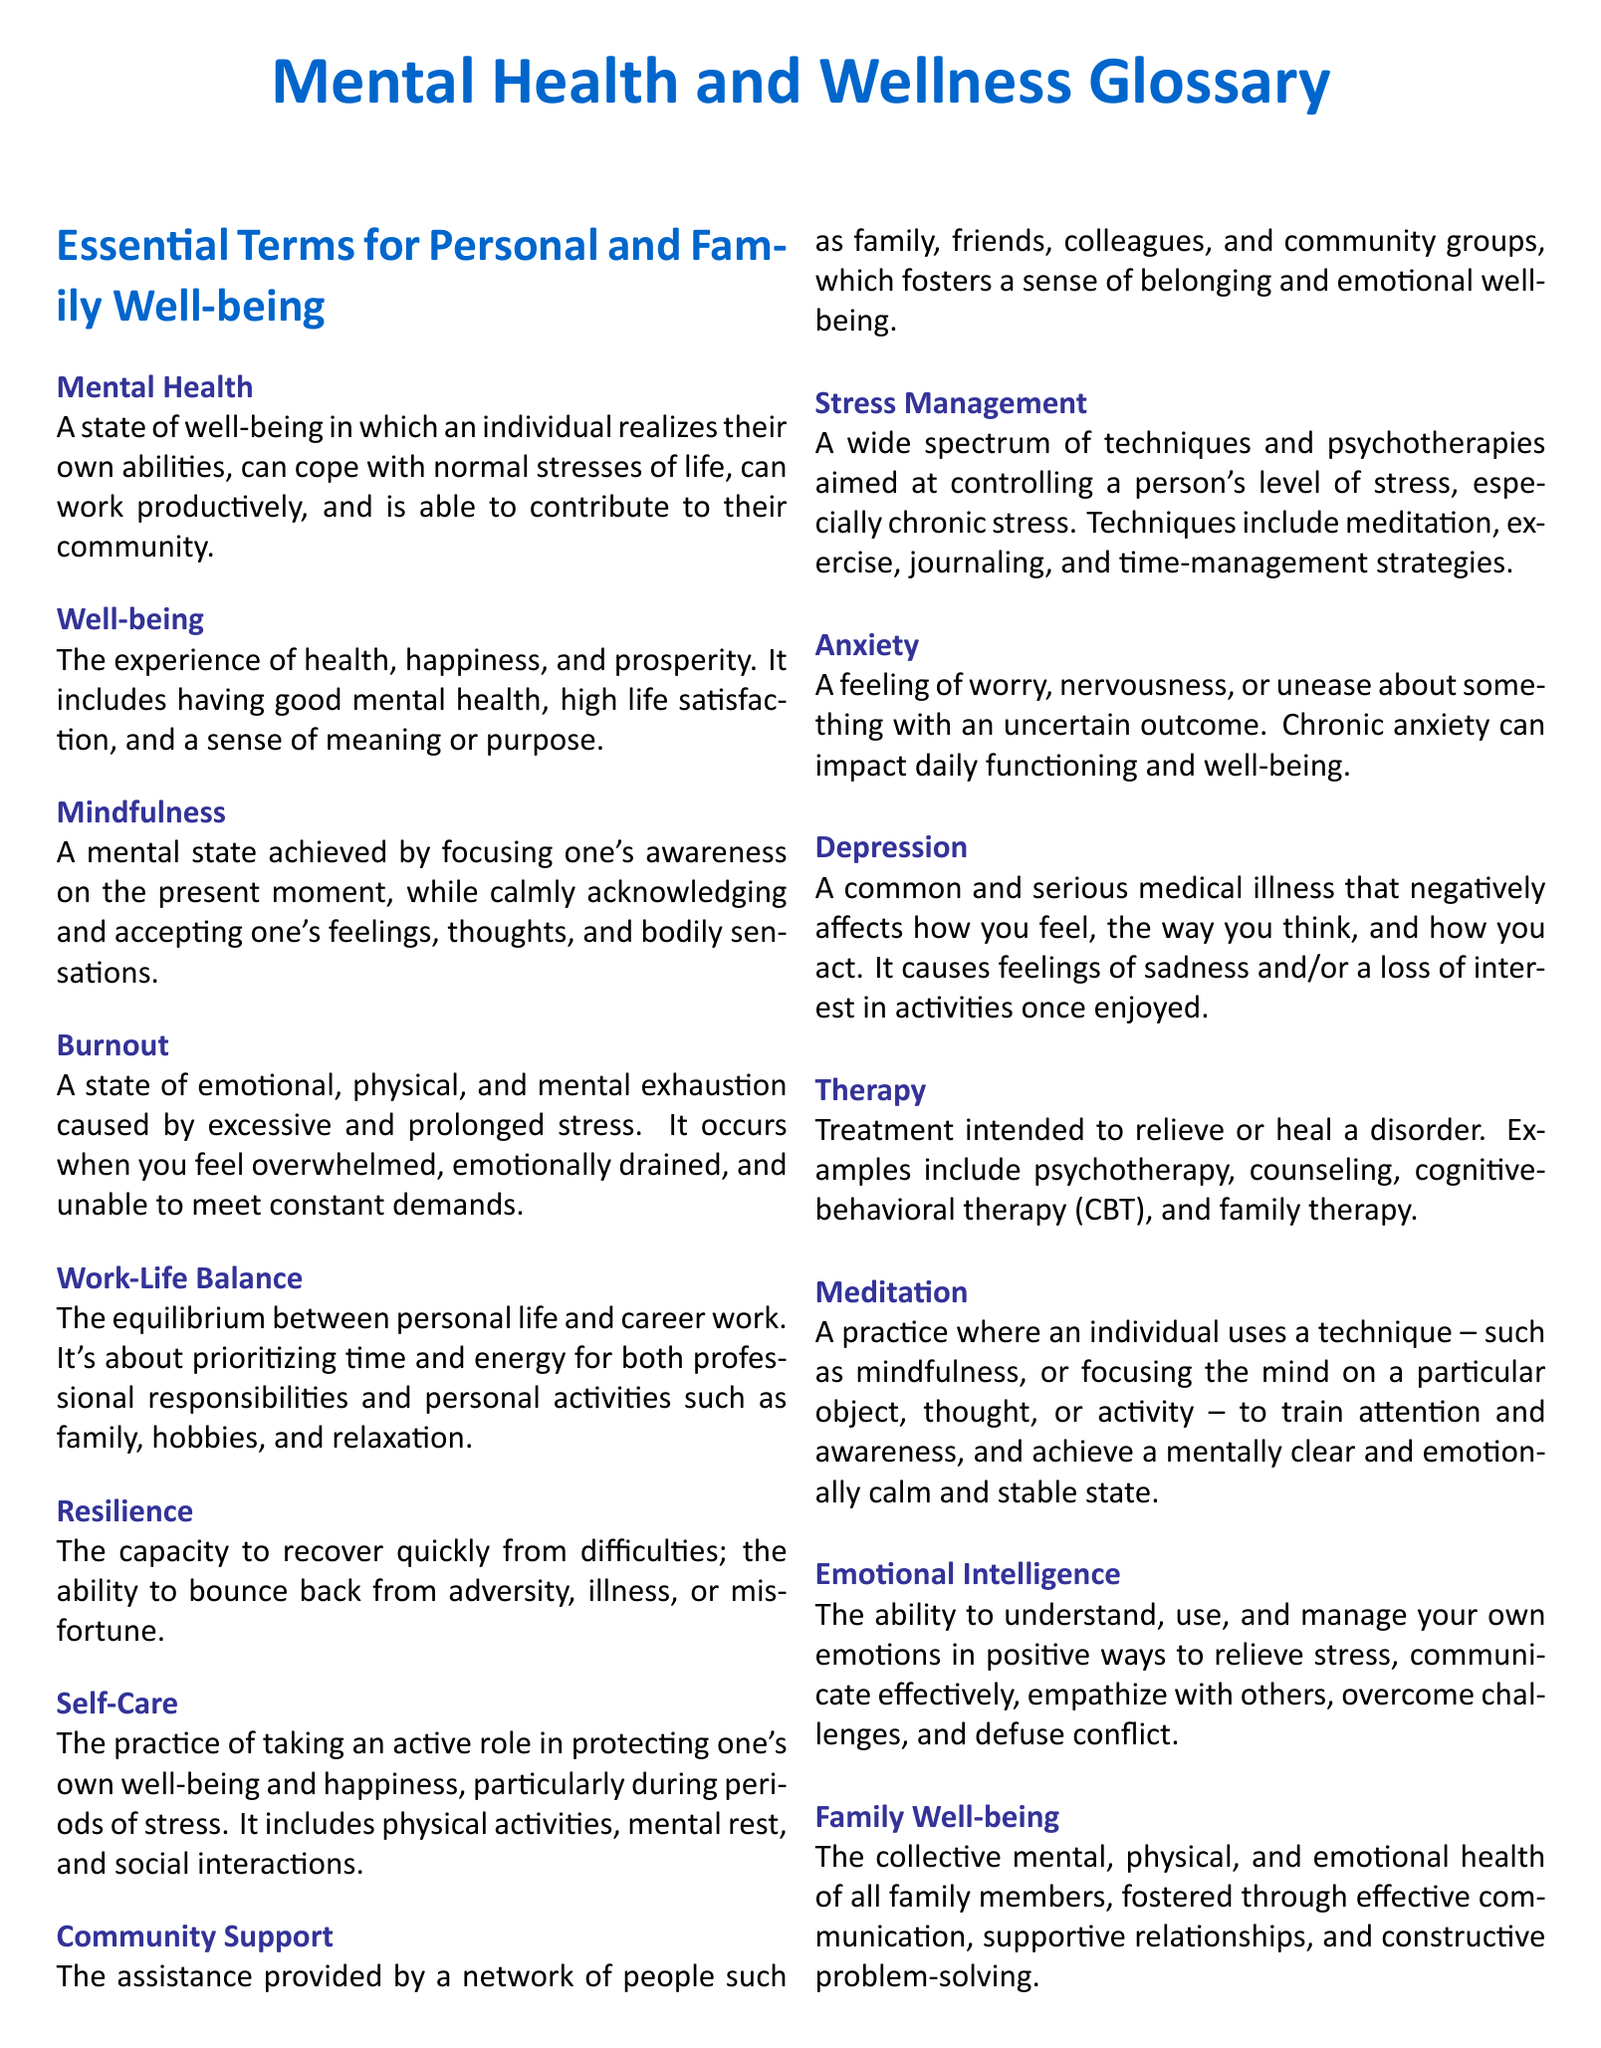What is the definition of Mental Health? Mental Health is defined as a state of well-being in which an individual realizes their own abilities, can cope with normal stresses of life, can work productively, and is able to contribute to their community.
Answer: A state of well-being What does the term Well-being encompass? Well-being includes the experience of health, happiness, and prosperity, covering aspects like good mental health, high life satisfaction, and a sense of meaning or purpose.
Answer: Health, happiness, and prosperity What is Burnout? Burnout is defined as a state of emotional, physical, and mental exhaustion caused by excessive and prolonged stress.
Answer: A state of exhaustion What practices are included in Self-Care? Self-Care includes physical activities, mental rest, and social interactions as practices to protect one's own well-being and happiness.
Answer: Physical activities, mental rest, and social interactions How does Community Support contribute to well-being? Community Support fosters a sense of belonging and emotional well-being through assistance by family, friends, colleagues, and community groups.
Answer: Sense of belonging and emotional well-being What is the relationship between Resilience and difficulties? Resilience refers to the capacity to recover quickly from difficulties, demonstrating the ability to bounce back from adversity, illness, or misfortune.
Answer: Recover quickly from difficulties What does Emotional Intelligence involve? Emotional Intelligence involves understanding, using, and managing your own emotions in positive ways.
Answer: Understanding and managing emotions What is a common treatment type mentioned in the glossary? A common treatment type listed in the glossary is psychotherapy.
Answer: Psychotherapy 